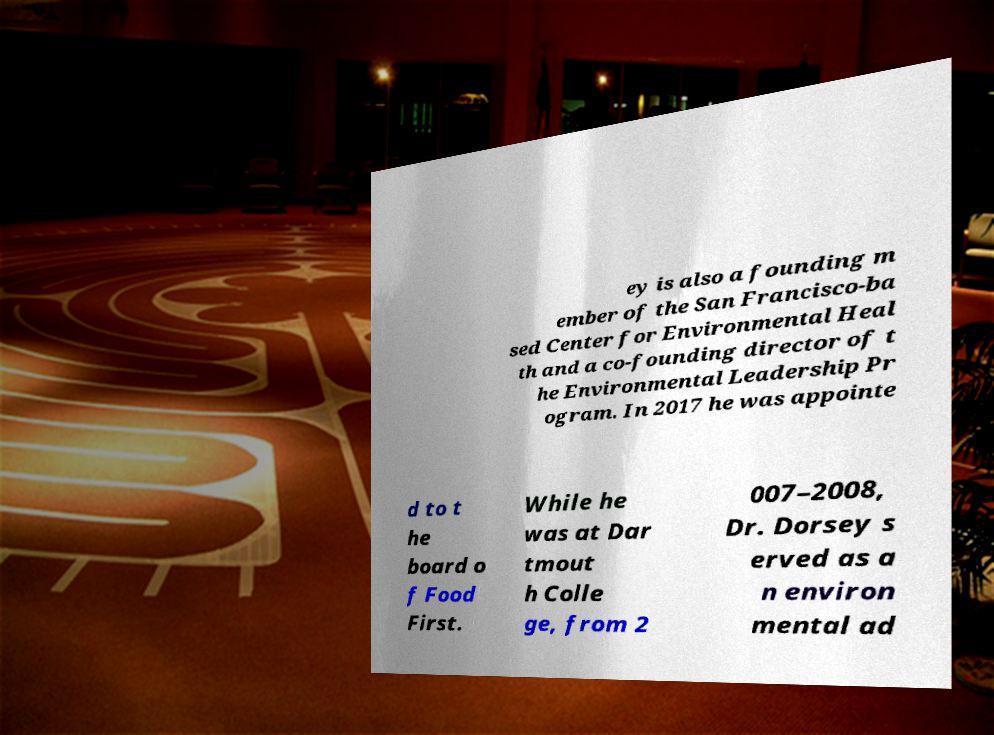Can you accurately transcribe the text from the provided image for me? ey is also a founding m ember of the San Francisco-ba sed Center for Environmental Heal th and a co-founding director of t he Environmental Leadership Pr ogram. In 2017 he was appointe d to t he board o f Food First. While he was at Dar tmout h Colle ge, from 2 007–2008, Dr. Dorsey s erved as a n environ mental ad 